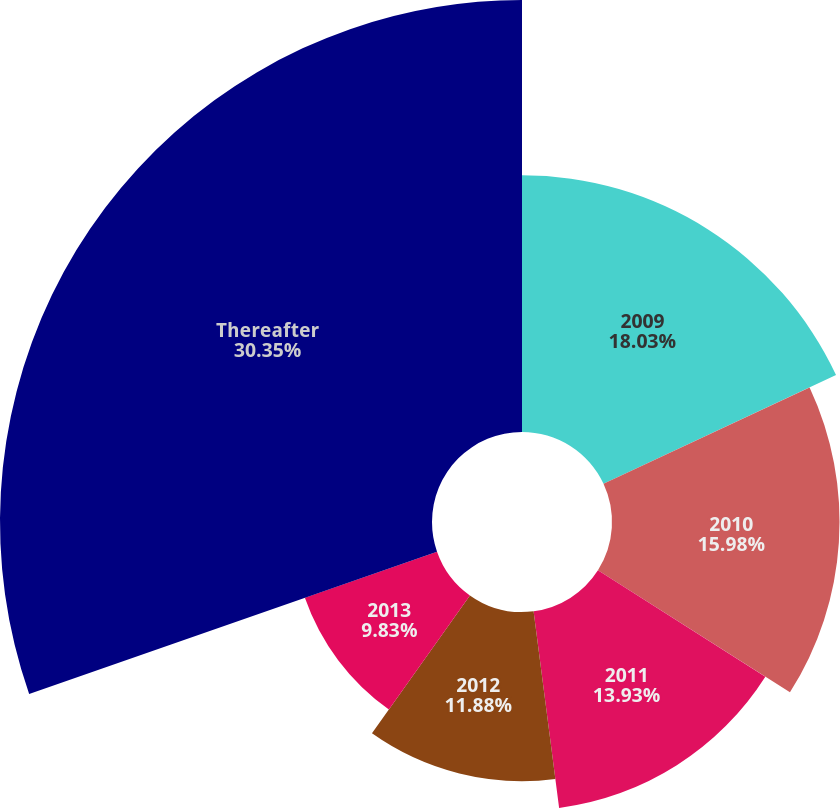<chart> <loc_0><loc_0><loc_500><loc_500><pie_chart><fcel>2009<fcel>2010<fcel>2011<fcel>2012<fcel>2013<fcel>Thereafter<nl><fcel>18.03%<fcel>15.98%<fcel>13.93%<fcel>11.88%<fcel>9.83%<fcel>30.34%<nl></chart> 